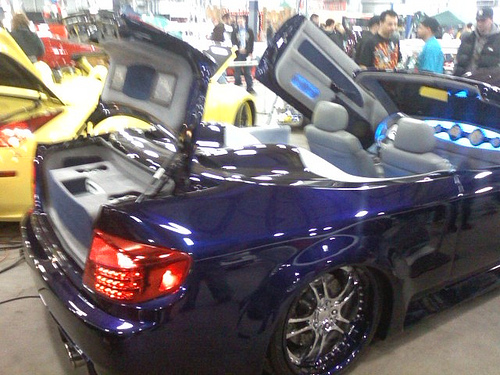<image>
Is the wheel on the car? No. The wheel is not positioned on the car. They may be near each other, but the wheel is not supported by or resting on top of the car. Is the car behind the man? No. The car is not behind the man. From this viewpoint, the car appears to be positioned elsewhere in the scene. 